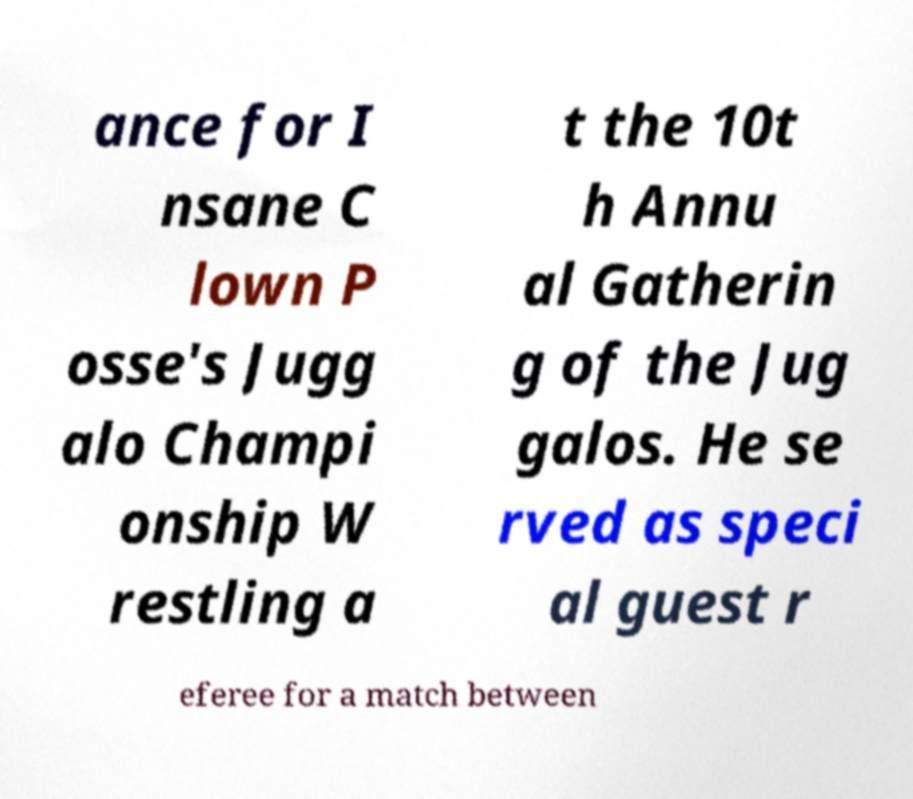I need the written content from this picture converted into text. Can you do that? ance for I nsane C lown P osse's Jugg alo Champi onship W restling a t the 10t h Annu al Gatherin g of the Jug galos. He se rved as speci al guest r eferee for a match between 